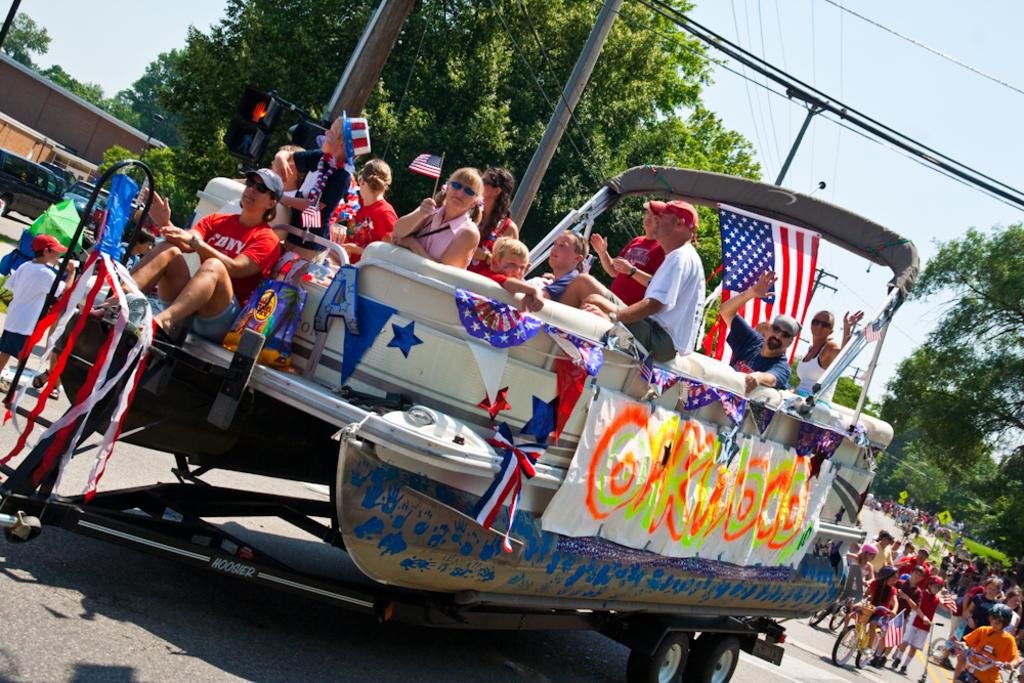What initials are on the sitting woman's shirt?
Provide a succinct answer. Fdny. Is the woman in red wearing a shirt for the fire department of new york?
Keep it short and to the point. Yes. 